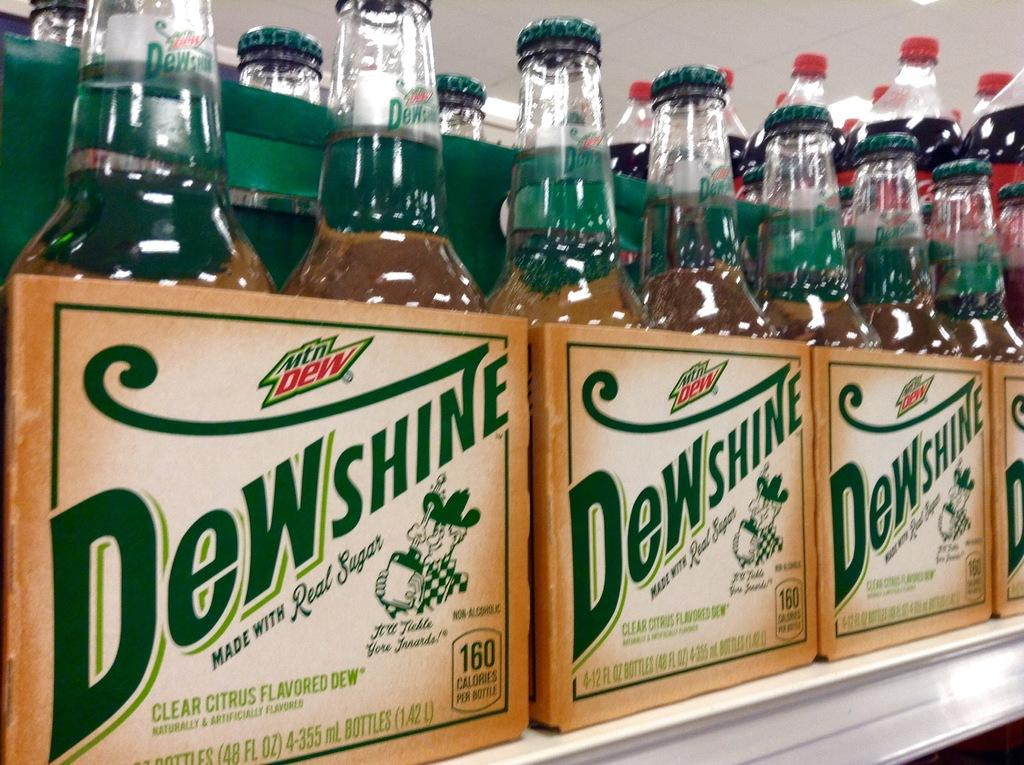What type of beverages are in the bottles in the image? The bottles contain cool drinks. How are the bottles arranged in the image? The bottles are placed in a rack. Where is the river located in the image? There is no river present in the image. How many hands are visible in the image? There are no hands visible in the image. 